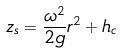<formula> <loc_0><loc_0><loc_500><loc_500>z _ { s } = \frac { \omega ^ { 2 } } { 2 g } r ^ { 2 } + h _ { c }</formula> 